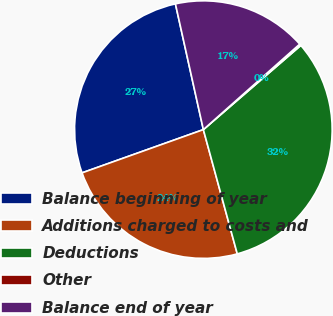Convert chart. <chart><loc_0><loc_0><loc_500><loc_500><pie_chart><fcel>Balance beginning of year<fcel>Additions charged to costs and<fcel>Deductions<fcel>Other<fcel>Balance end of year<nl><fcel>26.97%<fcel>23.79%<fcel>32.1%<fcel>0.21%<fcel>16.93%<nl></chart> 